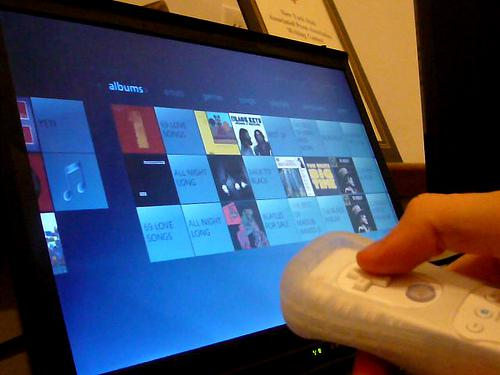Question: how is the selection made?
Choices:
A. With a pointer.
B. With a mouse.
C. With a keyboard.
D. With a Wii controller.
Answer with the letter. Answer: D Question: why is the finger on the direction control?
Choices:
A. To move image.
B. To move cursor.
C. To move the field position.
D. To change the screen.
Answer with the letter. Answer: B Question: what symbol is on the far left of the screen?
Choices:
A. A star.
B. A emoji.
C. An asterisk.
D. Musical note.
Answer with the letter. Answer: D 